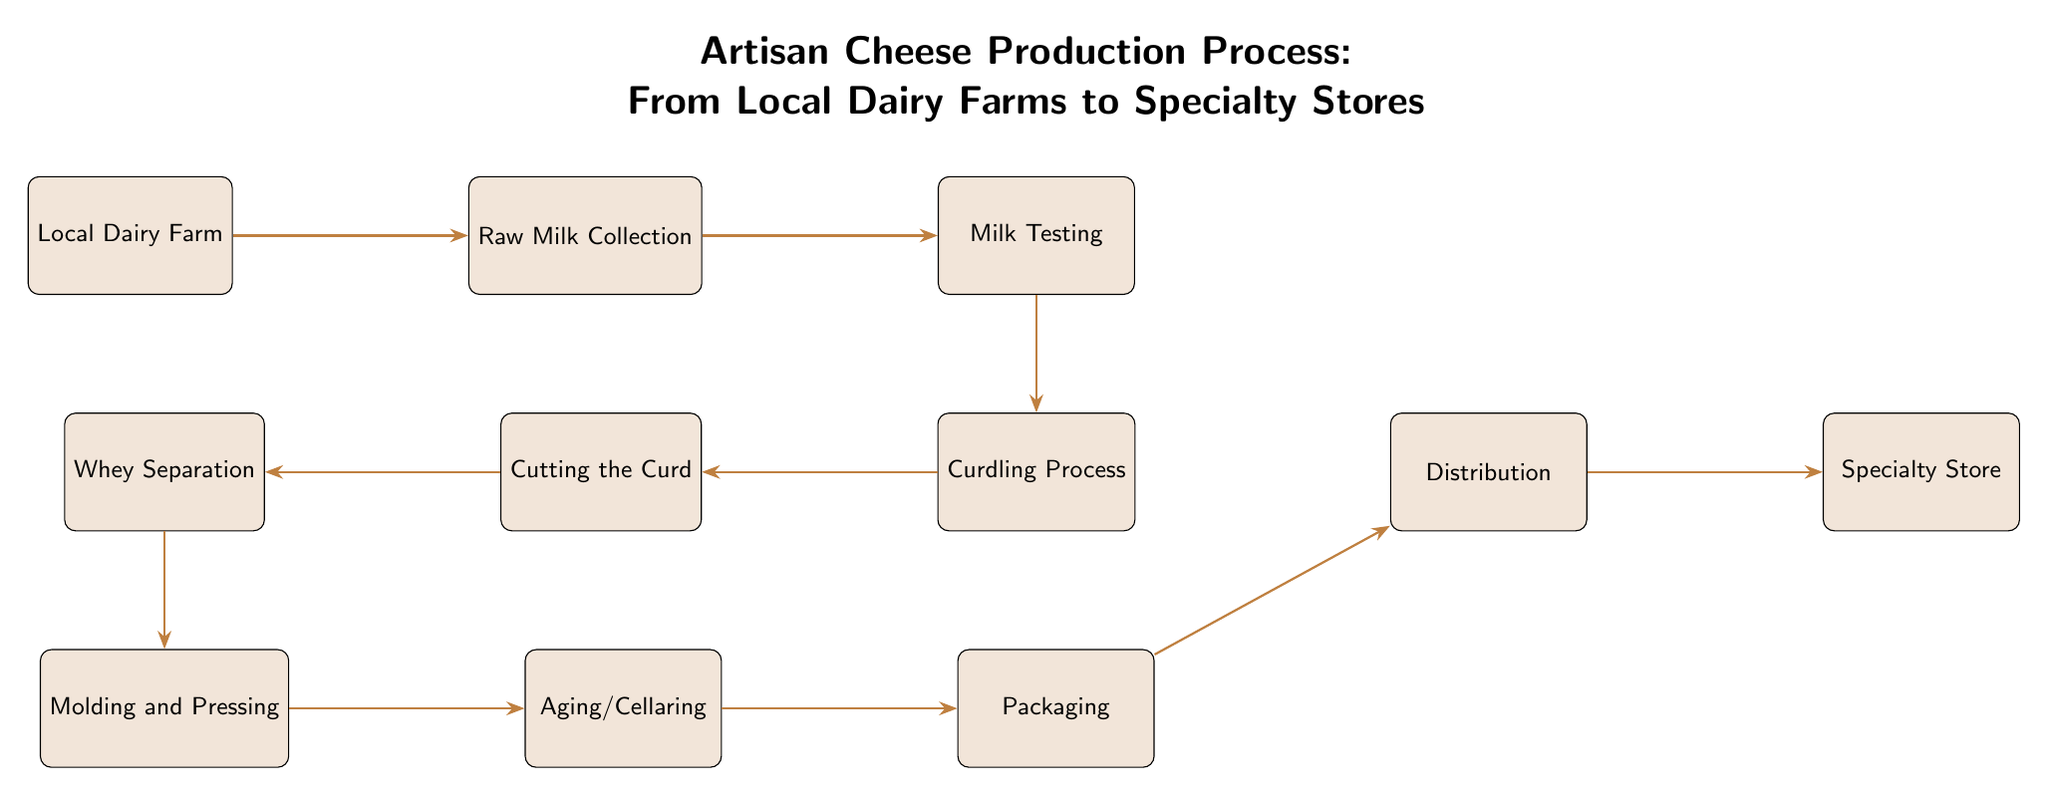What is the first step in the cheese production process? The diagram starts from the "Local Dairy Farm," which indicates that this is the first step where milk is sourced.
Answer: Local Dairy Farm How many main stages are there in the production process? Counting the main nodes from "Local Dairy Farm" to "Specialty Store," there are 9 distinct stages in total.
Answer: 9 What process follows raw milk collection? After "Raw Milk Collection," the next step in the flow is "Milk Testing," indicating that testing occurs before any processing of the milk.
Answer: Milk Testing Which step comes after aging? The diagram shows that "Packaging" follows "Aging/Cellaring," indicating that packaging occurs after the cheese has aged.
Answer: Packaging What is the final destination for the artisan cheese? The last node in the diagram is "Specialty Store," which is where the cheese is ultimately distributed for sale.
Answer: Specialty Store What step occurs before whey separation? Before "Whey Separation," the process is "Cutting the Curd," indicating that cutting is necessary prior to separating whey.
Answer: Cutting the Curd What type of testing occurs in the milk testing stage? The "Milk Testing" stage typically includes quality control tests to ensure the raw milk meets safety and quality standards before proceeding to curdling.
Answer: Quality Control Tests How does raw milk travel through the process? The arrows indicate a directed flow, showing that the raw milk moves sequentially from "Raw Milk Collection" to "Milk Testing" and onward through the other steps until it reaches the “Specialty Store.”
Answer: Sequential Flow What happens to the curd after the curdling process? After "Curdling Process," the flow directs to "Cutting the Curd," indicating that cutting occurs immediately after curdling to shape the cheese.
Answer: Cutting the Curd 